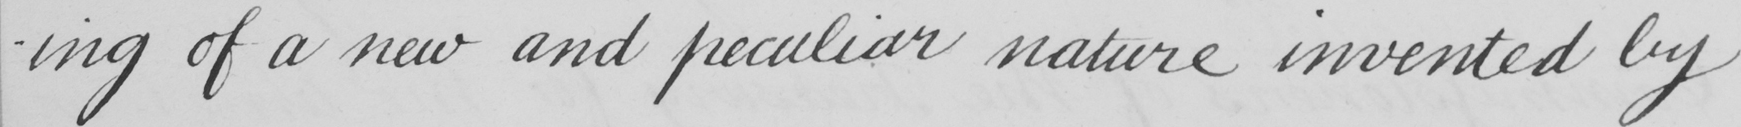Transcribe the text shown in this historical manuscript line. -ing of a new and peculiar nature invented by 